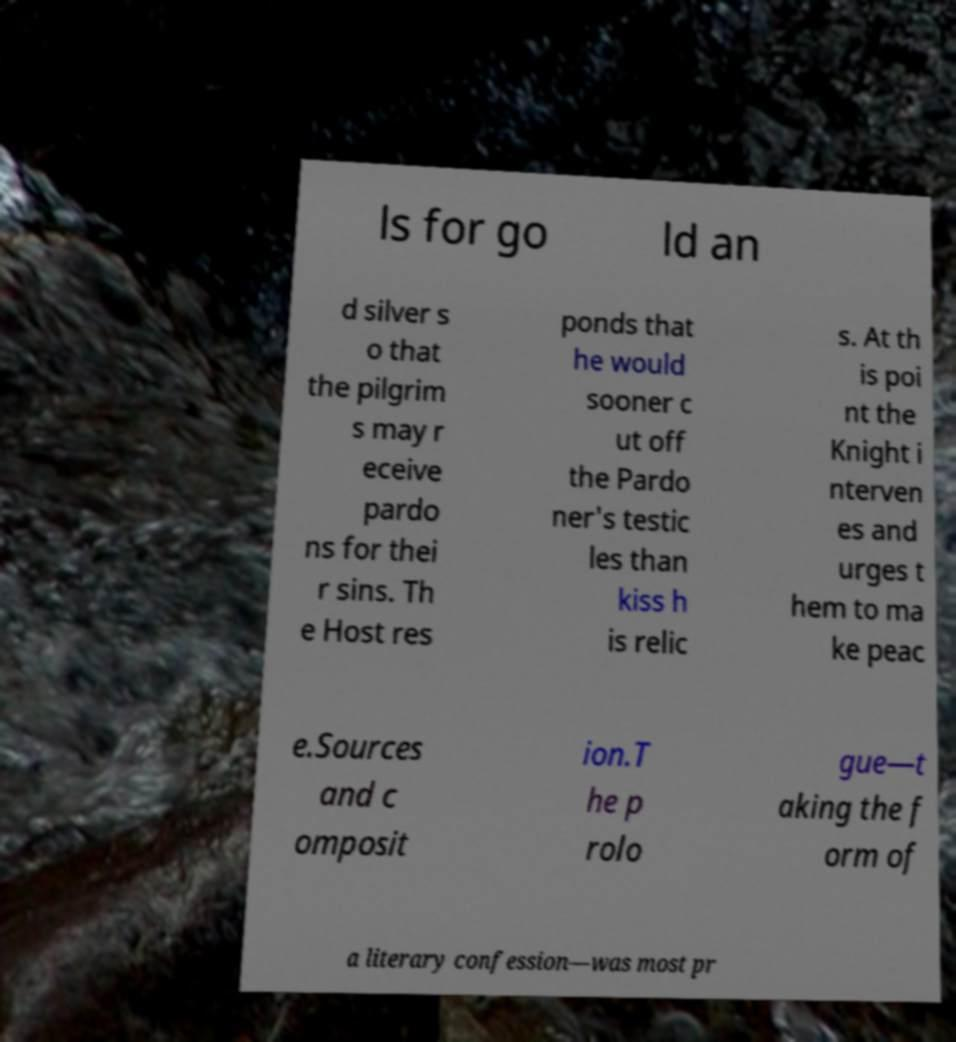Please identify and transcribe the text found in this image. ls for go ld an d silver s o that the pilgrim s may r eceive pardo ns for thei r sins. Th e Host res ponds that he would sooner c ut off the Pardo ner's testic les than kiss h is relic s. At th is poi nt the Knight i nterven es and urges t hem to ma ke peac e.Sources and c omposit ion.T he p rolo gue—t aking the f orm of a literary confession—was most pr 